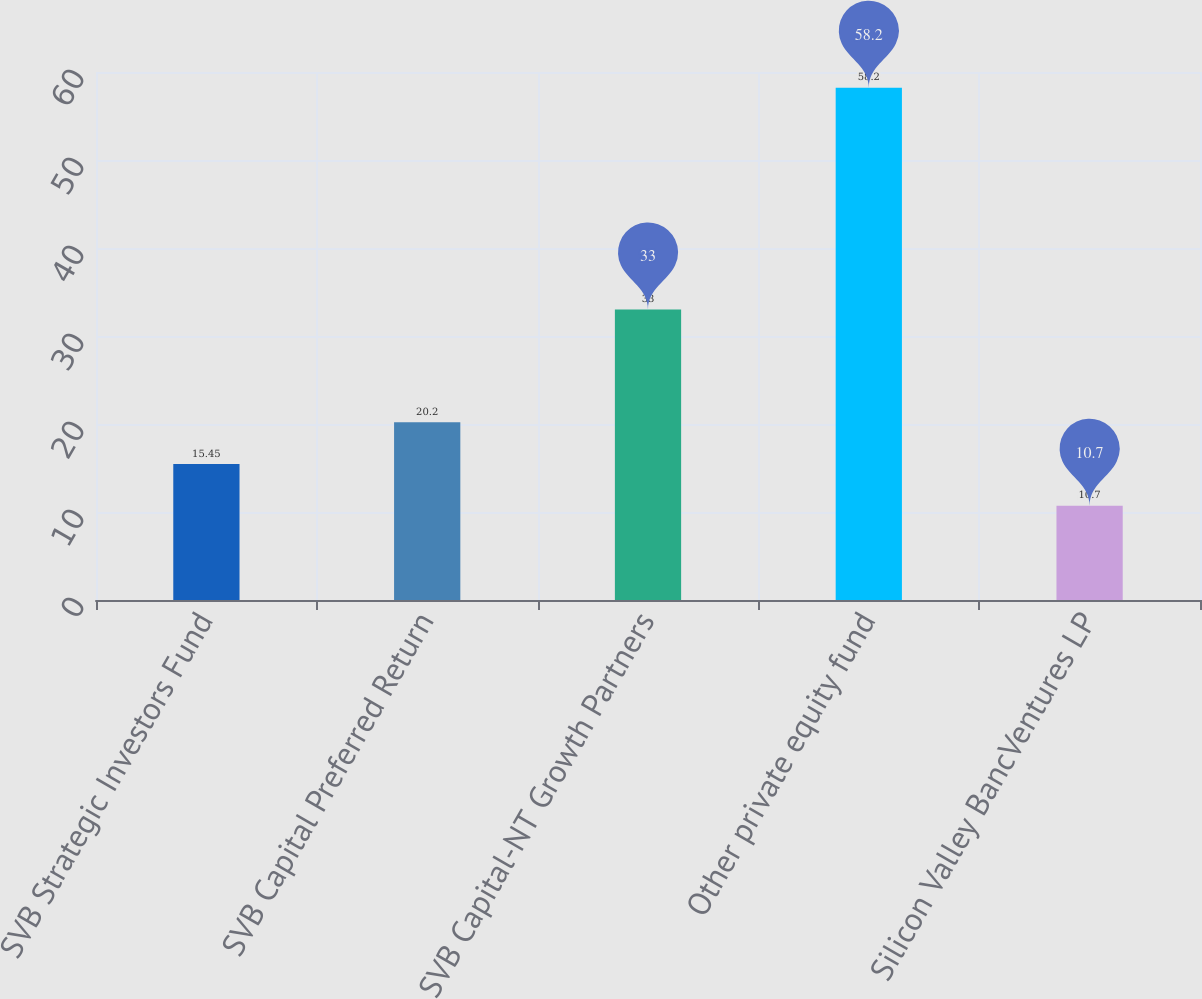Convert chart to OTSL. <chart><loc_0><loc_0><loc_500><loc_500><bar_chart><fcel>SVB Strategic Investors Fund<fcel>SVB Capital Preferred Return<fcel>SVB Capital-NT Growth Partners<fcel>Other private equity fund<fcel>Silicon Valley BancVentures LP<nl><fcel>15.45<fcel>20.2<fcel>33<fcel>58.2<fcel>10.7<nl></chart> 